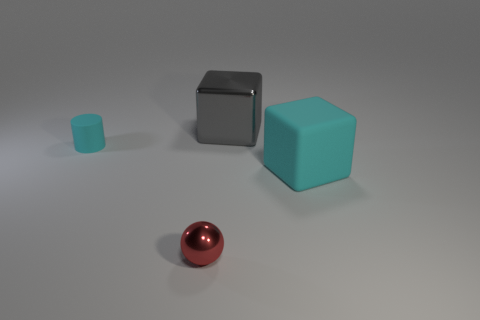Add 1 small cyan matte cylinders. How many objects exist? 5 Subtract all cylinders. How many objects are left? 3 Add 3 shiny spheres. How many shiny spheres exist? 4 Subtract 0 brown balls. How many objects are left? 4 Subtract all brown blocks. Subtract all purple cylinders. How many blocks are left? 2 Subtract all tiny red metal objects. Subtract all gray blocks. How many objects are left? 2 Add 2 small red spheres. How many small red spheres are left? 3 